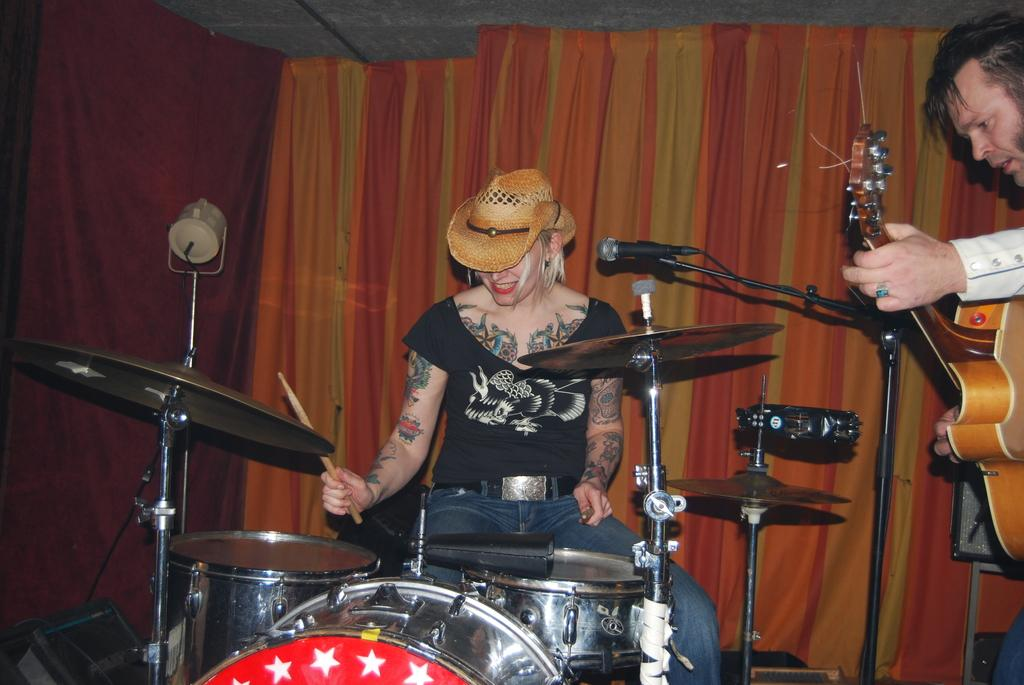What type of window treatment is visible in the image? There are curtains in the image. How many people are present in the image? There are two people in the image. Can you describe the woman in the image? The woman is playing musical drums. What is the man in the image holding? The man is holding a guitar. How many clocks can be seen on the wall in the image? There are no clocks visible in the image. What is the distance between the two people in the image? The distance between the two people cannot be determined from the image alone, as there is no reference point for measurement. 